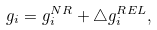<formula> <loc_0><loc_0><loc_500><loc_500>g _ { i } = g _ { i } ^ { N R } + \bigtriangleup g _ { i } ^ { R E L } ,</formula> 